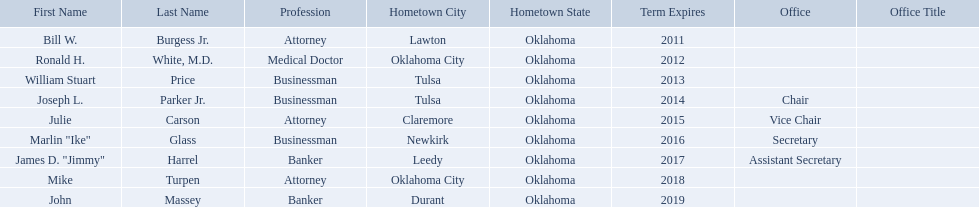What are all of the names? Bill W. Burgess Jr., Ronald H. White, M.D., William Stuart Price, Joseph L. Parker Jr., Julie Carson, Marlin "Ike" Glass, James D. "Jimmy" Harrel, Mike Turpen, John Massey. Where is each member from? Lawton, Oklahoma City, Tulsa, Tulsa, Claremore, Newkirk, Leedy, Oklahoma City, Durant. Along with joseph l. parker jr., which other member is from tulsa? William Stuart Price. Would you be able to parse every entry in this table? {'header': ['First Name', 'Last Name', 'Profession', 'Hometown City', 'Hometown State', 'Term Expires', 'Office', 'Office Title'], 'rows': [['Bill W.', 'Burgess Jr.', 'Attorney', 'Lawton', 'Oklahoma', '2011', '', ''], ['Ronald H.', 'White, M.D.', 'Medical Doctor', 'Oklahoma City', 'Oklahoma', '2012', '', ''], ['William Stuart', 'Price', 'Businessman', 'Tulsa', 'Oklahoma', '2013', '', ''], ['Joseph L.', 'Parker Jr.', 'Businessman', 'Tulsa', 'Oklahoma', '2014', 'Chair', ''], ['Julie', 'Carson', 'Attorney', 'Claremore', 'Oklahoma', '2015', 'Vice Chair', ''], ['Marlin "Ike"', 'Glass', 'Businessman', 'Newkirk', 'Oklahoma', '2016', 'Secretary', ''], ['James D. "Jimmy"', 'Harrel', 'Banker', 'Leedy', 'Oklahoma', '2017', 'Assistant Secretary', ''], ['Mike', 'Turpen', 'Attorney', 'Oklahoma City', 'Oklahoma', '2018', '', ''], ['John', 'Massey', 'Banker', 'Durant', 'Oklahoma', '2019', '', '']]} Where is bill w. burgess jr. from? Lawton. Where is price and parker from? Tulsa. Who is from the same state as white? Mike Turpen. 